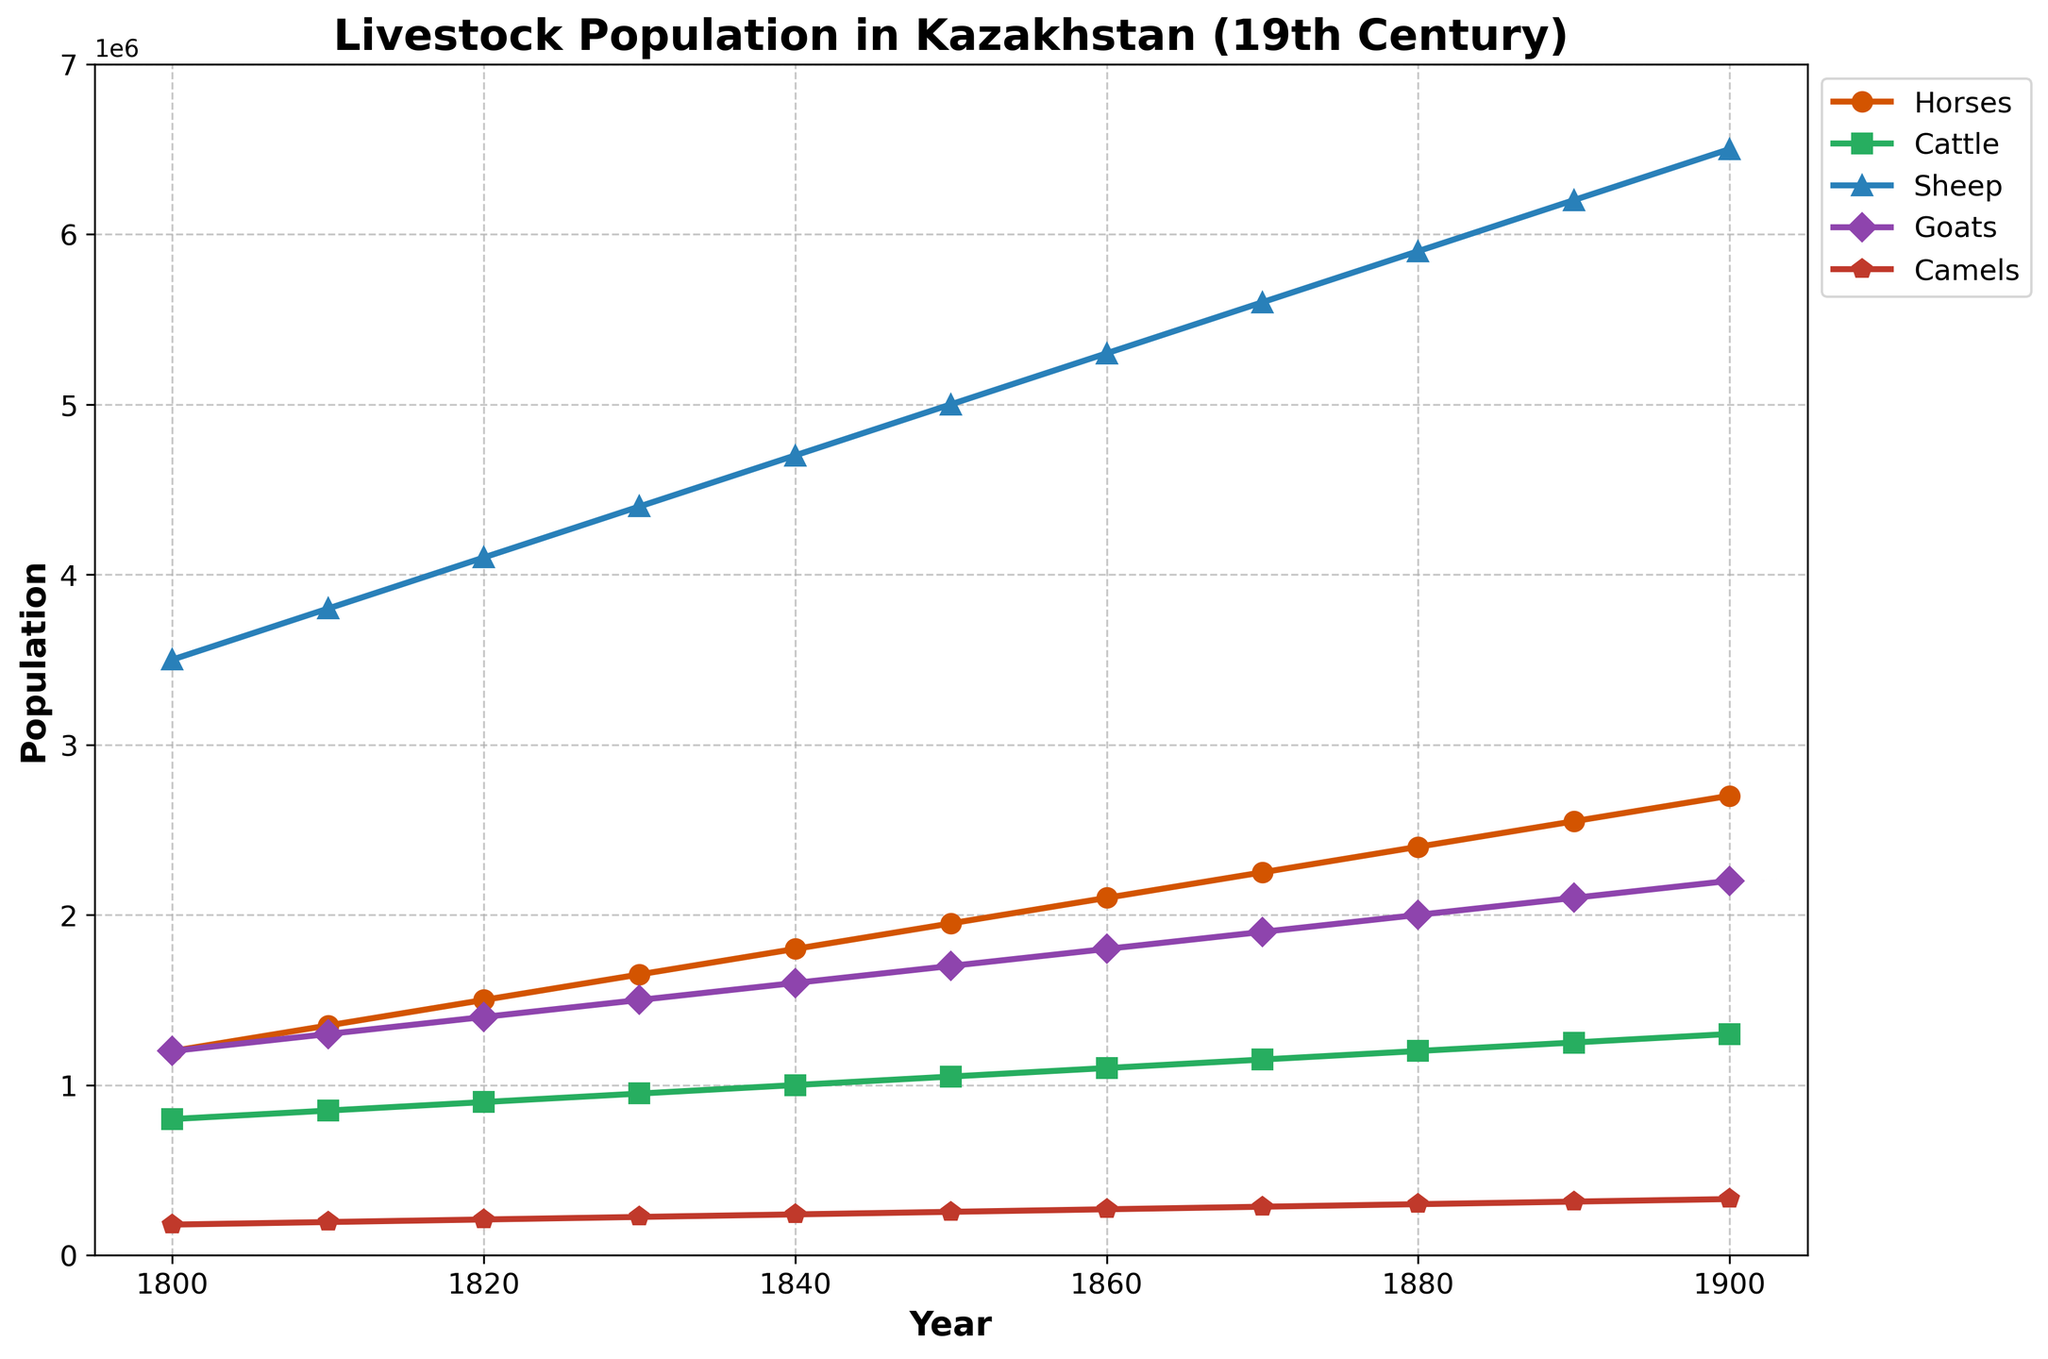What is the population of sheep in 1830? Referring to the line chart, locate the year 1830 on the x-axis, then trace upwards to the line representing sheep. The corresponding y-axis value is the population of sheep for that year.
Answer: 4,400,000 Which livestock had the highest population in 1850? Look at the 1850 mark on the x-axis and compare the heights of the lines representing different livestock populations. The line that is at the highest point on the y-axis represents the livestock with the highest population.
Answer: Sheep How many more horses were there in 1900 compared to 1800? Find the population of horses in 1900 and in 1800 by referring to the y-values at these points on the x-axis. Subtract the population in 1800 from the population in 1900.
Answer: 1,500,000 What is the difference in population between cattle and camels in 1880? Locate the populations of cattle and camels in 1880 on the y-axis. Subtract the number of camels from the number of cattle.
Answer: 900,000 In which decade did the goat population reach 1,600,000? Find the line representing goats and trace to find the point where it first reaches 1,600,000 on the y-axis. Then trace downwards to find the corresponding year on the x-axis.
Answer: 1840 What was the growth in the sheep population from 1810 to 1820? Find the sheep population for 1810 and 1820 on the y-axis. Subtract the 1810 value from the 1820 value.
Answer: 300,000 By how much did the cattle population increase from 1800 to 1900? Locate the cattle population for 1800 and 1900 on the y-axis. Subtract the 1800 value from the 1900 value.
Answer: 500,000 Which livestock population grew the fastest from 1800 to 1900 relative to its initial population? Calculate the growth rate for each livestock by subtracting the 1800 value from the 1900 value and then dividing by the 1800 value. Compare these growth rates to determine which is the highest.
Answer: Sheep 